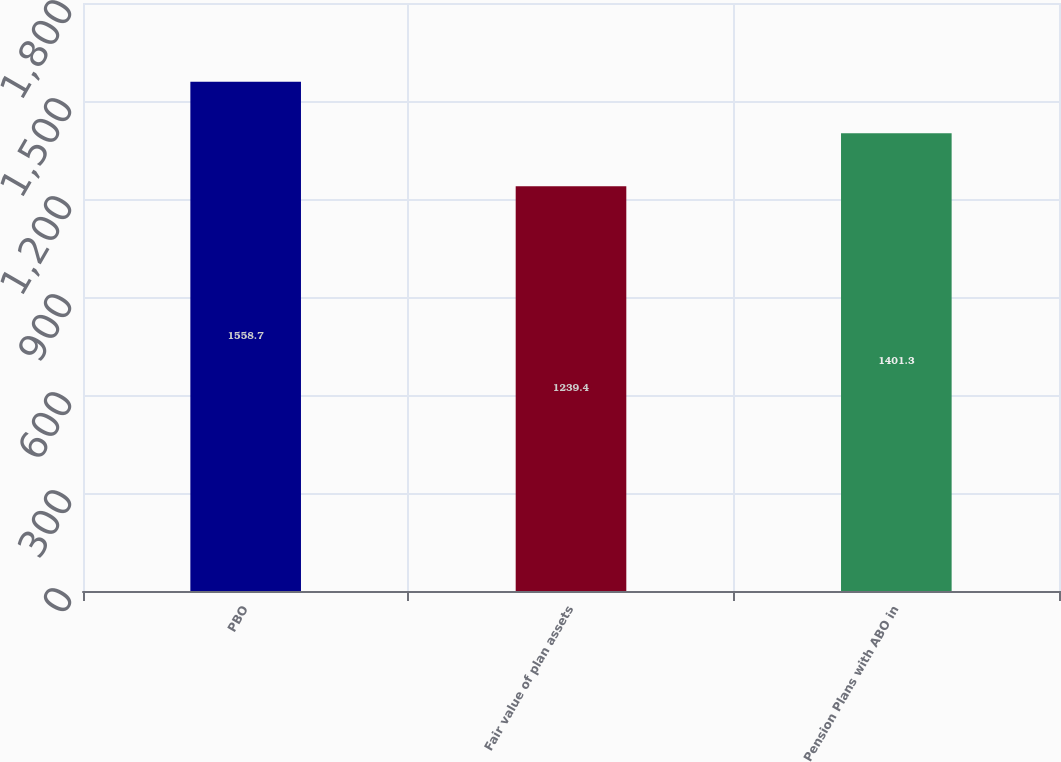Convert chart to OTSL. <chart><loc_0><loc_0><loc_500><loc_500><bar_chart><fcel>PBO<fcel>Fair value of plan assets<fcel>Pension Plans with ABO in<nl><fcel>1558.7<fcel>1239.4<fcel>1401.3<nl></chart> 